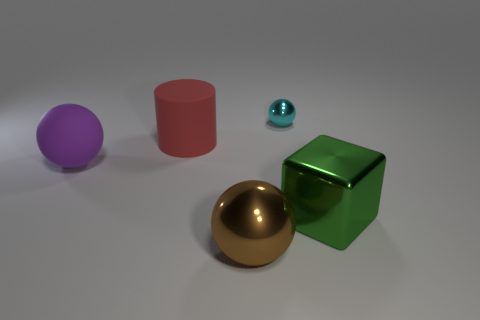Subtract all rubber balls. How many balls are left? 2 Add 2 small cyan matte blocks. How many objects exist? 7 Subtract all brown balls. How many balls are left? 2 Subtract all cylinders. How many objects are left? 4 Subtract all yellow balls. Subtract all gray cubes. How many balls are left? 3 Subtract all brown metal spheres. Subtract all large metallic spheres. How many objects are left? 3 Add 3 green things. How many green things are left? 4 Add 2 brown metallic things. How many brown metallic things exist? 3 Subtract 0 brown cubes. How many objects are left? 5 